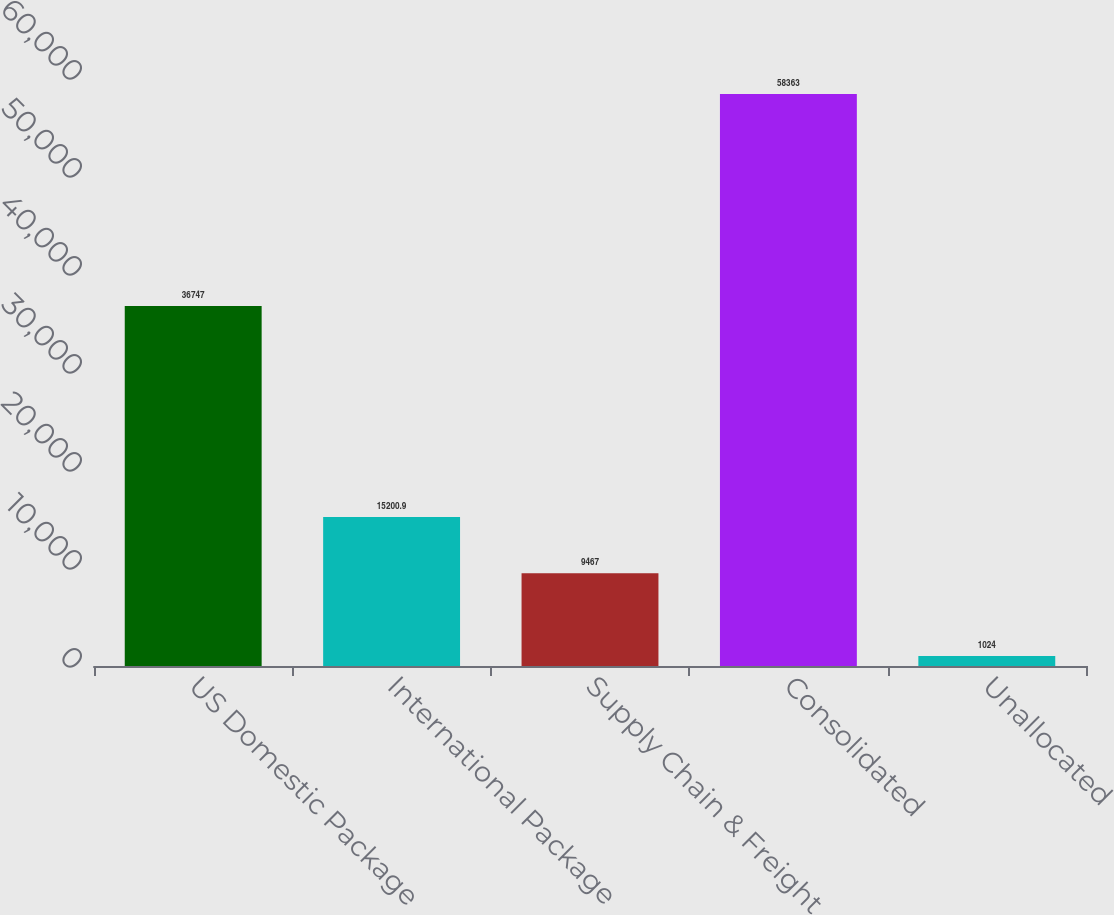<chart> <loc_0><loc_0><loc_500><loc_500><bar_chart><fcel>US Domestic Package<fcel>International Package<fcel>Supply Chain & Freight<fcel>Consolidated<fcel>Unallocated<nl><fcel>36747<fcel>15200.9<fcel>9467<fcel>58363<fcel>1024<nl></chart> 